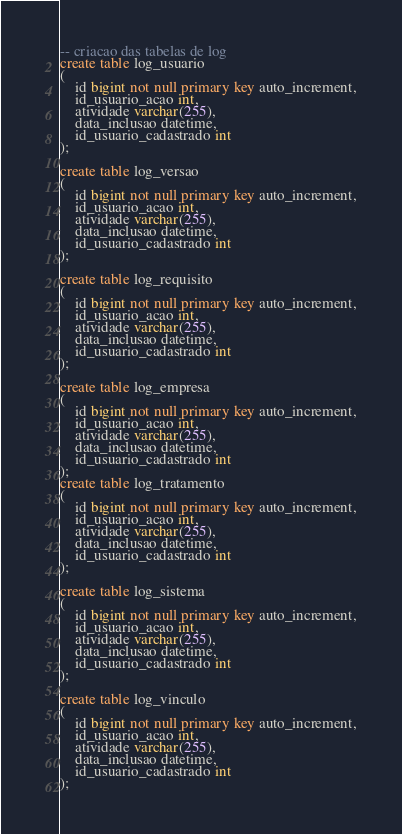Convert code to text. <code><loc_0><loc_0><loc_500><loc_500><_SQL_>-- criacao das tabelas de log
create table log_usuario
( 
	id bigint not null primary key auto_increment,
    id_usuario_acao int, 
    atividade varchar(255), 
    data_inclusao datetime,
    id_usuario_cadastrado int   
);

create table log_versao
( 
	id bigint not null primary key auto_increment,
    id_usuario_acao int, 
    atividade varchar(255), 
    data_inclusao datetime,
    id_usuario_cadastrado int   
);

create table log_requisito
( 
	id bigint not null primary key auto_increment,
    id_usuario_acao int, 
    atividade varchar(255), 
    data_inclusao datetime,
    id_usuario_cadastrado int   
);

create table log_empresa
( 
	id bigint not null primary key auto_increment,
    id_usuario_acao int, 
    atividade varchar(255), 
    data_inclusao datetime,
    id_usuario_cadastrado int   
);
create table log_tratamento
( 
	id bigint not null primary key auto_increment,
    id_usuario_acao int, 
    atividade varchar(255), 
    data_inclusao datetime,
    id_usuario_cadastrado int   
);

create table log_sistema
( 
	id bigint not null primary key auto_increment,
    id_usuario_acao int, 
    atividade varchar(255), 
    data_inclusao datetime,
    id_usuario_cadastrado int   
);

create table log_vinculo
( 
	id bigint not null primary key auto_increment,
    id_usuario_acao int, 
    atividade varchar(255), 
    data_inclusao datetime,
    id_usuario_cadastrado int   
);</code> 